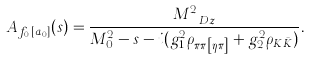<formula> <loc_0><loc_0><loc_500><loc_500>A _ { f _ { 0 } [ a _ { 0 } ] } ( s ) = \frac { M _ { \ D z } ^ { 2 } } { M _ { 0 } ^ { 2 } - s - i ( g _ { 1 } ^ { 2 } \rho _ { \pi \pi \left [ \eta \pi \right ] } + g _ { 2 } ^ { 2 } \rho _ { K \bar { K } } ) } .</formula> 